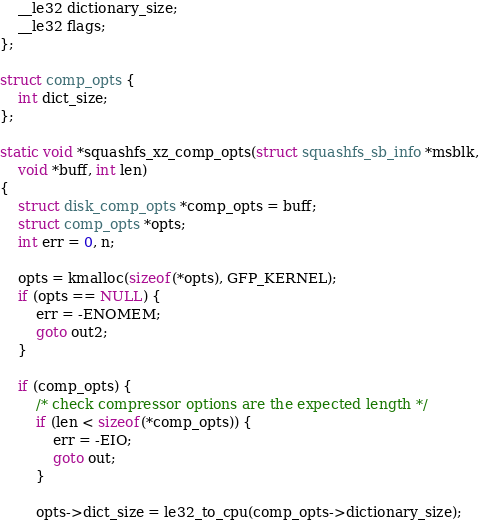<code> <loc_0><loc_0><loc_500><loc_500><_C_>	__le32 dictionary_size;
	__le32 flags;
};

struct comp_opts {
	int dict_size;
};

static void *squashfs_xz_comp_opts(struct squashfs_sb_info *msblk,
	void *buff, int len)
{
	struct disk_comp_opts *comp_opts = buff;
	struct comp_opts *opts;
	int err = 0, n;

	opts = kmalloc(sizeof(*opts), GFP_KERNEL);
	if (opts == NULL) {
		err = -ENOMEM;
		goto out2;
	}

	if (comp_opts) {
		/* check compressor options are the expected length */
		if (len < sizeof(*comp_opts)) {
			err = -EIO;
			goto out;
		}

		opts->dict_size = le32_to_cpu(comp_opts->dictionary_size);
</code> 